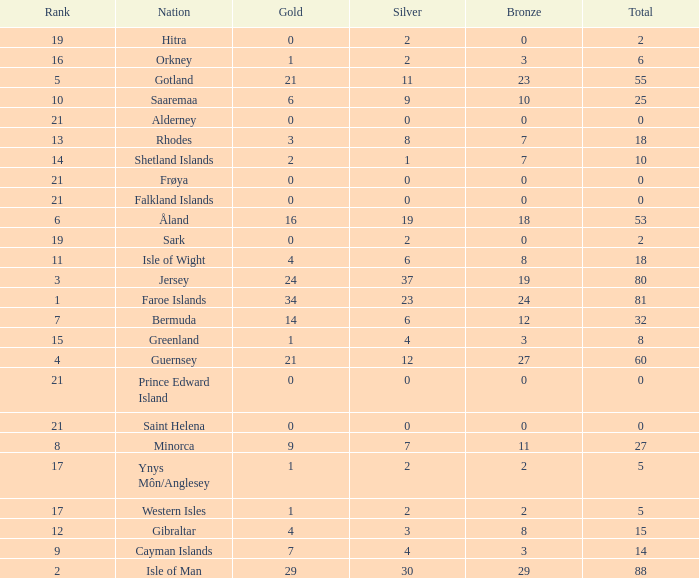How many Silver medals were won in total by all those with more than 3 bronze and exactly 16 gold? 19.0. Could you help me parse every detail presented in this table? {'header': ['Rank', 'Nation', 'Gold', 'Silver', 'Bronze', 'Total'], 'rows': [['19', 'Hitra', '0', '2', '0', '2'], ['16', 'Orkney', '1', '2', '3', '6'], ['5', 'Gotland', '21', '11', '23', '55'], ['10', 'Saaremaa', '6', '9', '10', '25'], ['21', 'Alderney', '0', '0', '0', '0'], ['13', 'Rhodes', '3', '8', '7', '18'], ['14', 'Shetland Islands', '2', '1', '7', '10'], ['21', 'Frøya', '0', '0', '0', '0'], ['21', 'Falkland Islands', '0', '0', '0', '0'], ['6', 'Åland', '16', '19', '18', '53'], ['19', 'Sark', '0', '2', '0', '2'], ['11', 'Isle of Wight', '4', '6', '8', '18'], ['3', 'Jersey', '24', '37', '19', '80'], ['1', 'Faroe Islands', '34', '23', '24', '81'], ['7', 'Bermuda', '14', '6', '12', '32'], ['15', 'Greenland', '1', '4', '3', '8'], ['4', 'Guernsey', '21', '12', '27', '60'], ['21', 'Prince Edward Island', '0', '0', '0', '0'], ['21', 'Saint Helena', '0', '0', '0', '0'], ['8', 'Minorca', '9', '7', '11', '27'], ['17', 'Ynys Môn/Anglesey', '1', '2', '2', '5'], ['17', 'Western Isles', '1', '2', '2', '5'], ['12', 'Gibraltar', '4', '3', '8', '15'], ['9', 'Cayman Islands', '7', '4', '3', '14'], ['2', 'Isle of Man', '29', '30', '29', '88']]} 